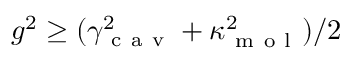Convert formula to latex. <formula><loc_0><loc_0><loc_500><loc_500>g ^ { 2 } \geq ( \gamma _ { c a v } ^ { 2 } + \kappa _ { m o l } ^ { 2 } ) / 2</formula> 